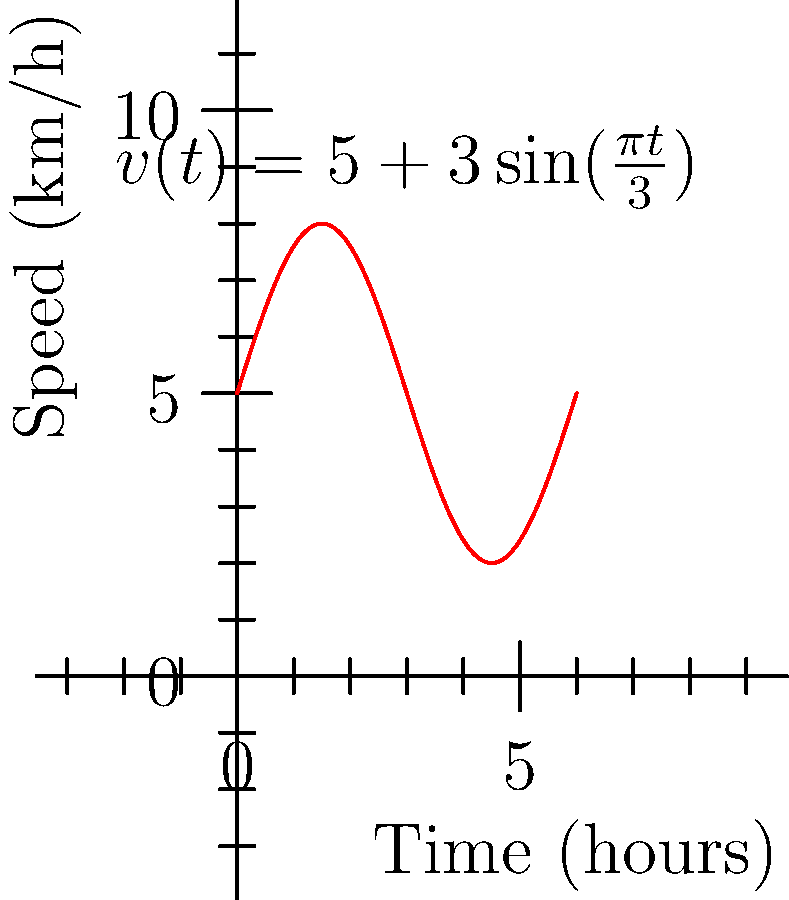During a thrilling river rafting expedition in the Kaveri River near Bangalore, your raft's speed in km/h is given by the function $v(t) = 5 + 3\sin(\frac{\pi t}{3})$, where $t$ is the time in hours. Calculate the total distance traveled during the first 6 hours of your adventure. To find the total distance traveled, we need to calculate the area under the speed-time curve from $t=0$ to $t=6$. This is done using a definite integral:

1) The distance is given by $d = \int_{0}^{6} v(t) dt$

2) Substituting the given function:
   $d = \int_{0}^{6} (5 + 3\sin(\frac{\pi t}{3})) dt$

3) Split the integral:
   $d = \int_{0}^{6} 5 dt + \int_{0}^{6} 3\sin(\frac{\pi t}{3}) dt$

4) Evaluate the first part:
   $\int_{0}^{6} 5 dt = 5t|_{0}^{6} = 5(6) - 5(0) = 30$

5) For the second part, use substitution:
   Let $u = \frac{\pi t}{3}$, then $du = \frac{\pi}{3} dt$ or $dt = \frac{3}{\pi} du$
   When $t=0$, $u=0$; when $t=6$, $u=2\pi$

6) Rewrite the second integral:
   $\int_{0}^{6} 3\sin(\frac{\pi t}{3}) dt = \frac{9}{\pi} \int_{0}^{2\pi} \sin(u) du$

7) Evaluate:
   $\frac{9}{\pi} [-\cos(u)]_{0}^{2\pi} = \frac{9}{\pi} [-\cos(2\pi) + \cos(0)] = 0$

8) Sum the results:
   $d = 30 + 0 = 30$

Therefore, the total distance traveled is 30 km.
Answer: 30 km 